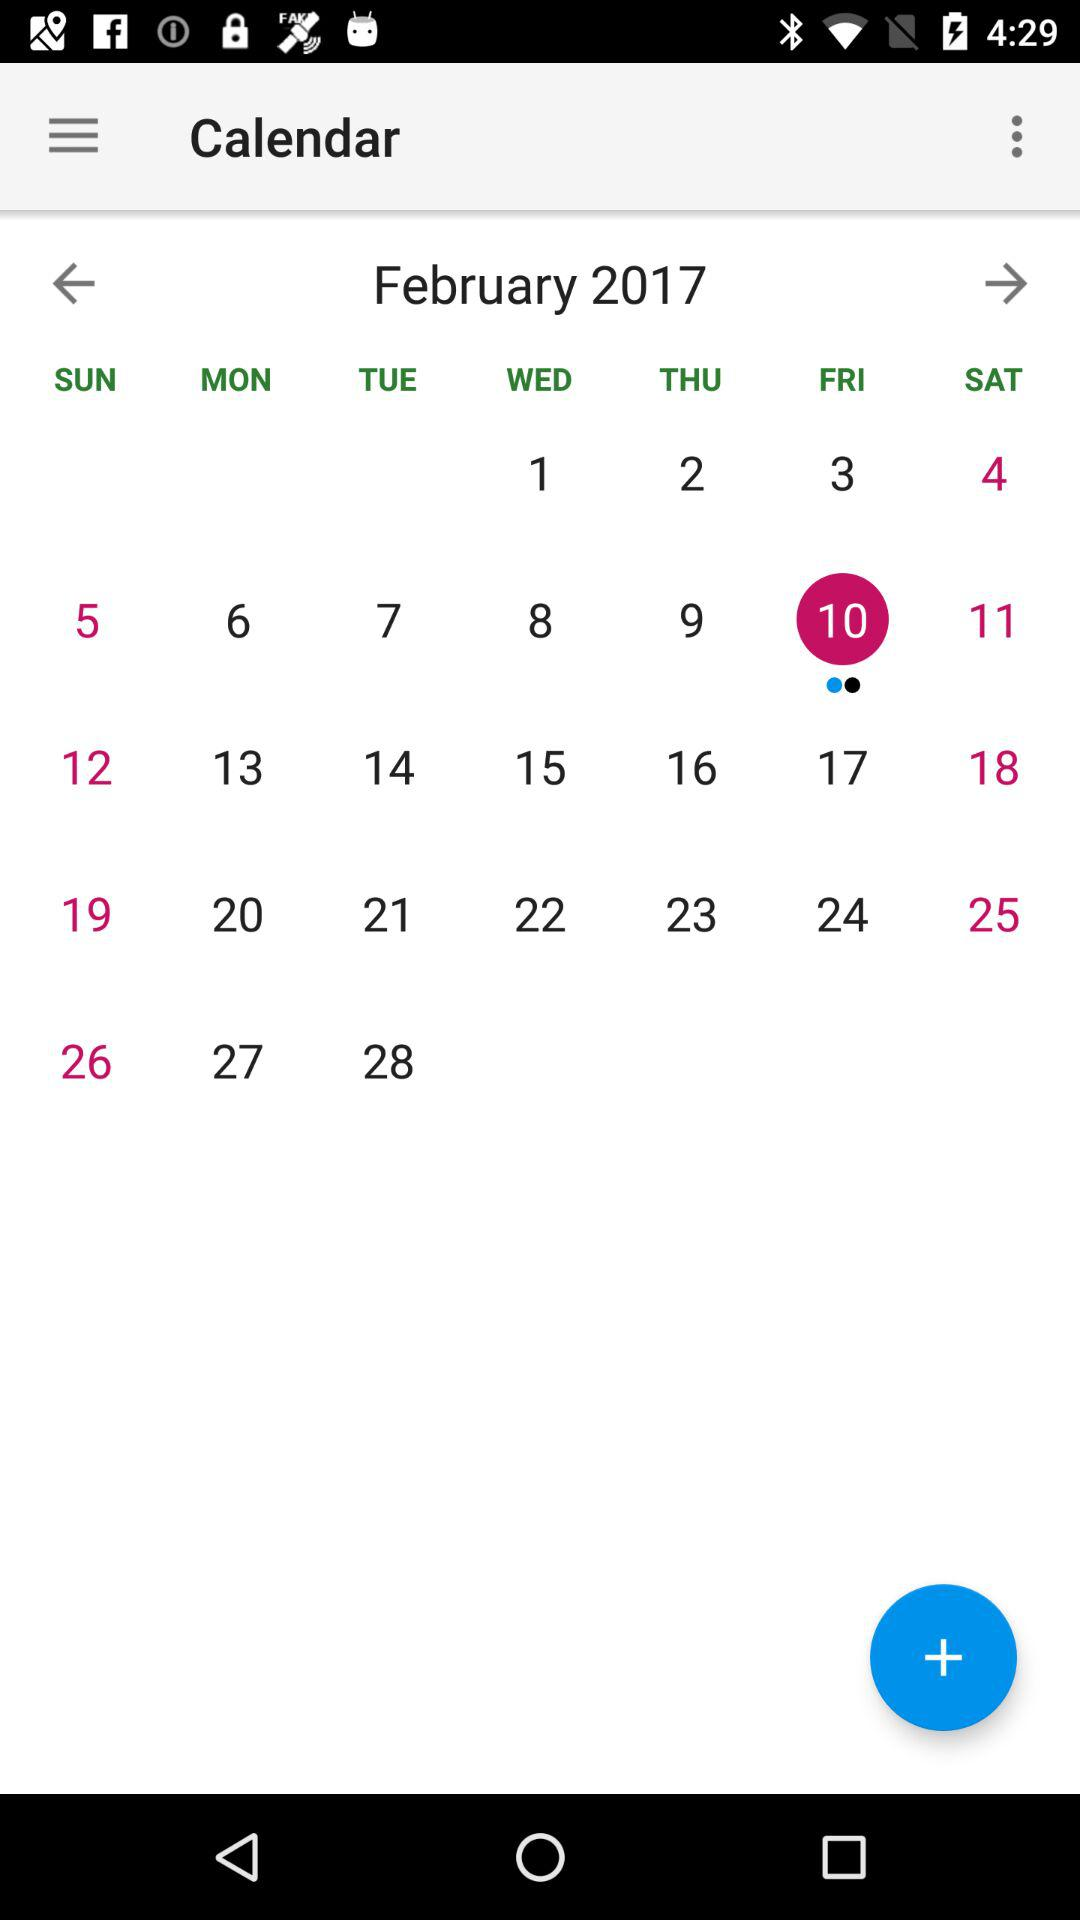What is the application name? The application name is "Calendar". 